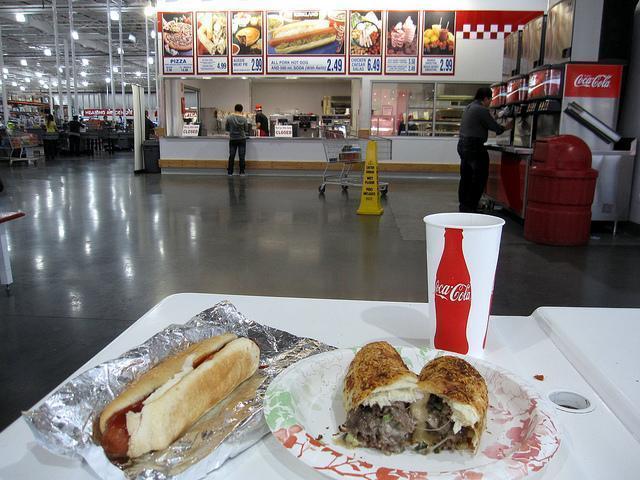Do both options have cheese on them?
Indicate the correct response by choosing from the four available options to answer the question.
Options: Maybe, yes, unsure, no. No. 